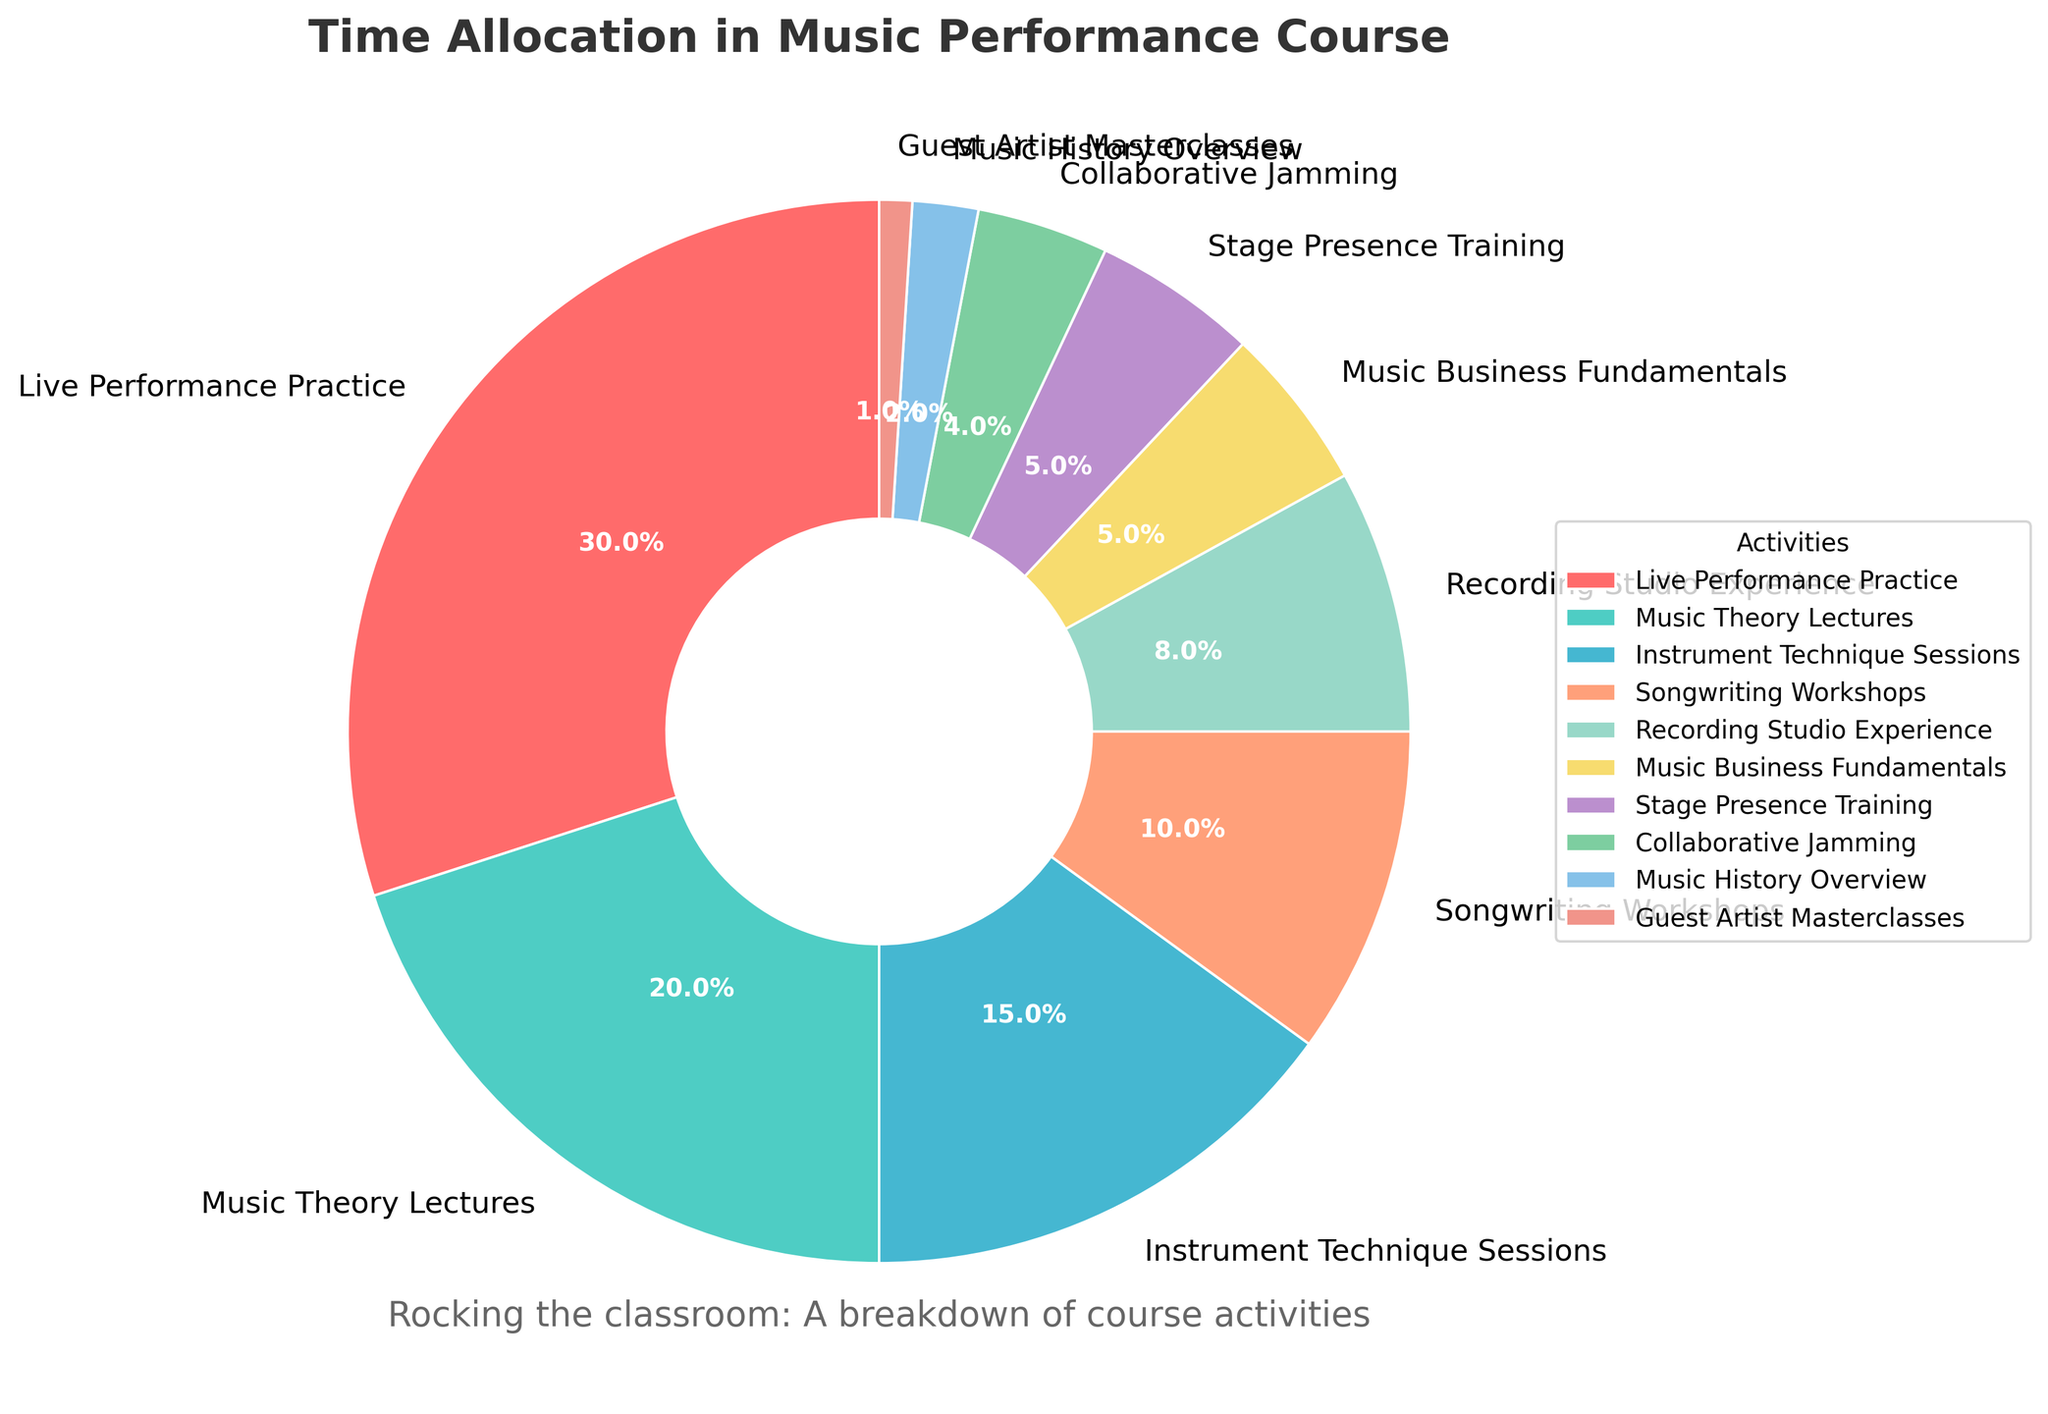What's the activity with the highest percentage of time allocation? The segment with the highest value in the pie chart represents the activity with the largest percentage of time allocation. From the pie chart, it's clear that "Live Performance Practice" has the largest segment, which is labeled with 30%.
Answer: Live Performance Practice How much more time is spent on Music Theory Lectures compared to Guest Artist Masterclasses? Locate both Music Theory Lectures and Guest Artist Masterclasses slices. Music Theory Lectures is 20%, and Guest Artist Masterclasses is 1%. Calculate the difference: 20% - 1% = 19%.
Answer: 19% Which activity has the smallest allocation, and what percentage does it represent? The smallest segment in the pie chart corresponds to the activity with the smallest percentage. The chart shows that "Guest Artist Masterclasses" has the smallest percentage, which is labeled as 1%.
Answer: Guest Artist Masterclasses, 1% What is the total percentage of time allocated to Instrument Technique Sessions, Songwriting Workshops, and Recording Studio Experience combined? Find the percentages for Instrument Technique Sessions (15%), Songwriting Workshops (10%), and Recording Studio Experience (8%). Sum them up: 15% + 10% + 8% = 33%.
Answer: 33% How many activities have an allocation of 5% or less, and what are they? Identify the segments that are labeled with 5% or less. They are: Music Business Fundamentals (5%), Stage Presence Training (5%), Collaborative Jamming (4%), Music History Overview (2%), and Guest Artist Masterclasses (1%). Count these activities: 5.
Answer: 5, Music Business Fundamentals, Stage Presence Training, Collaborative Jamming, Music History Overview, Guest Artist Masterclasses Comparing Live Performance Practice and Collaborative Jamming, what is the ratio of their time allocations? Live Performance Practice has 30% and Collaborative Jamming has 4%. The ratio of Live Performance Practice to Collaborative Jamming is 30% / 4% = 7.5.
Answer: 7.5 Which visual feature of the pie chart helps in understanding that Live Performance Practice is the primary focus of the course? The size of the segment representing Live Performance Practice is the largest, and it is labeled with the highest percentage (30%), making it visually dominant.
Answer: The largest segment What is the combined percentage of the activities related to live performance and stage presence? Combine the percentages of Live Performance Practice (30%) and Stage Presence Training (5%). Sum them up: 30% + 5% = 35%.
Answer: 35% What is the difference in percentage allocation between Music Theory Lectures and Recording Studio Experience? Music Theory Lectures has 20% and Recording Studio Experience has 8%. Calculate the difference: 20% - 8% = 12%.
Answer: 12% Which two activities have the same percentage allocation, and what is that percentage? Identify pairs of activities with the same percentage. Music Business Fundamentals and Stage Presence Training both have 5%.
Answer: Music Business Fundamentals and Stage Presence Training, 5% 